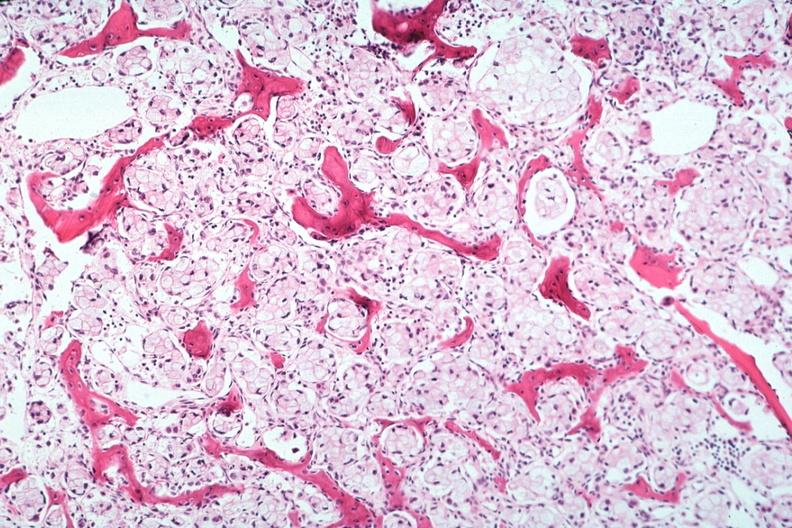s surface of nodes seen externally in slide present?
Answer the question using a single word or phrase. No 